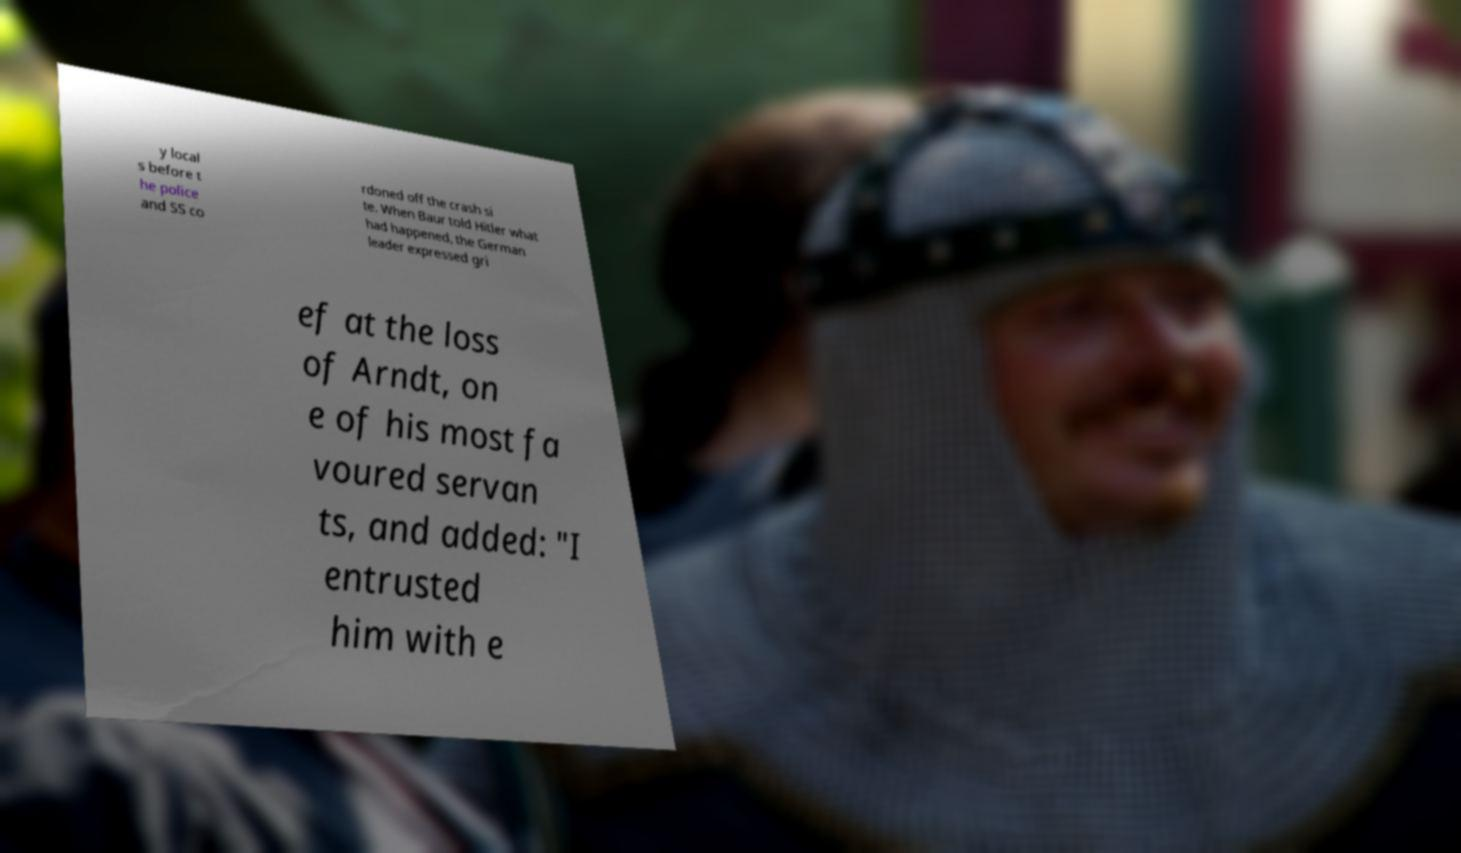I need the written content from this picture converted into text. Can you do that? y local s before t he police and SS co rdoned off the crash si te. When Baur told Hitler what had happened, the German leader expressed gri ef at the loss of Arndt, on e of his most fa voured servan ts, and added: "I entrusted him with e 